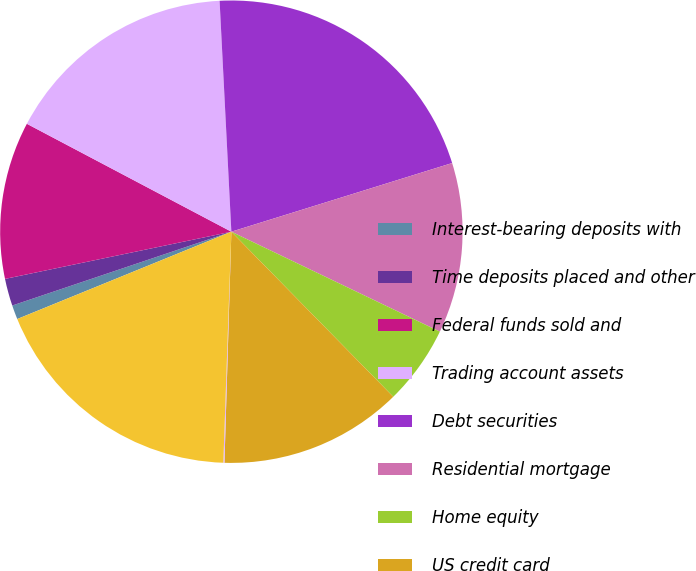Convert chart. <chart><loc_0><loc_0><loc_500><loc_500><pie_chart><fcel>Interest-bearing deposits with<fcel>Time deposits placed and other<fcel>Federal funds sold and<fcel>Trading account assets<fcel>Debt securities<fcel>Residential mortgage<fcel>Home equity<fcel>US credit card<fcel>Non-US credit card<fcel>Direct/Indirect consumer<nl><fcel>0.99%<fcel>1.9%<fcel>11.0%<fcel>16.46%<fcel>21.01%<fcel>11.91%<fcel>5.54%<fcel>12.82%<fcel>0.08%<fcel>18.28%<nl></chart> 